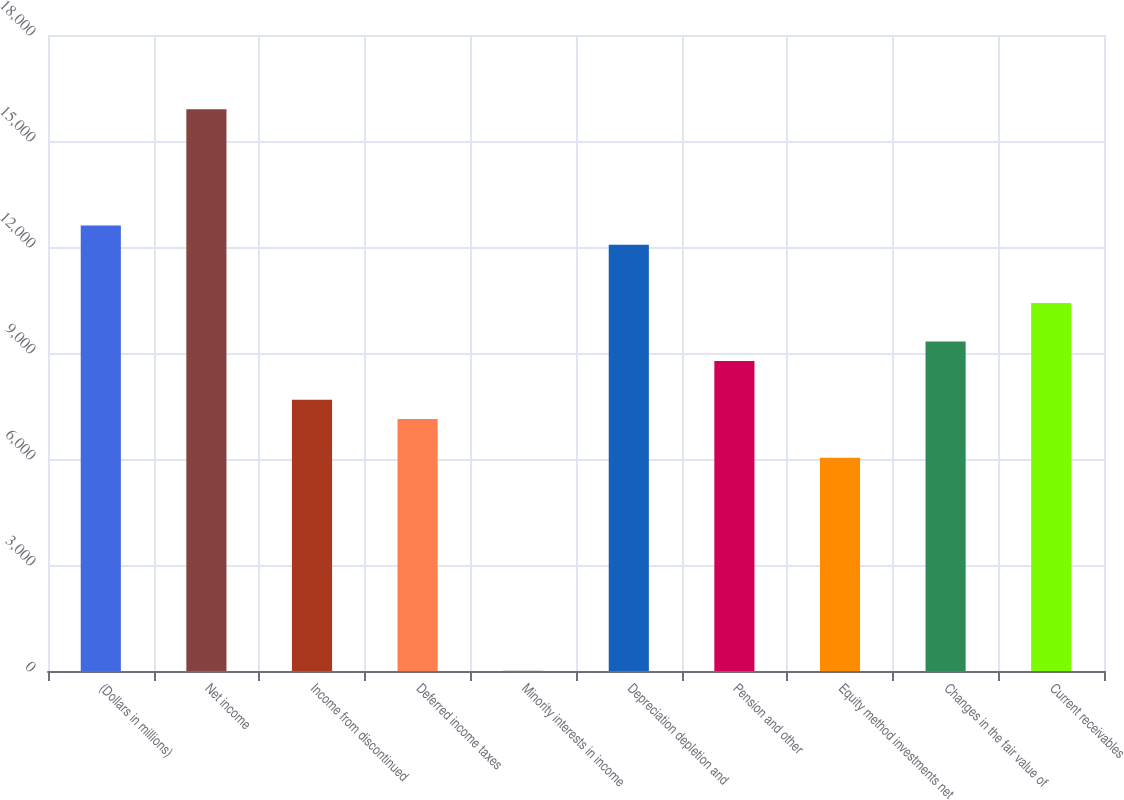<chart> <loc_0><loc_0><loc_500><loc_500><bar_chart><fcel>(Dollars in millions)<fcel>Net income<fcel>Income from discontinued<fcel>Deferred income taxes<fcel>Minority interests in income<fcel>Depreciation depletion and<fcel>Pension and other<fcel>Equity method investments net<fcel>Changes in the fair value of<fcel>Current receivables<nl><fcel>12609.4<fcel>15896.2<fcel>7679.2<fcel>7131.4<fcel>10<fcel>12061.6<fcel>8774.8<fcel>6035.8<fcel>9322.6<fcel>10418.2<nl></chart> 